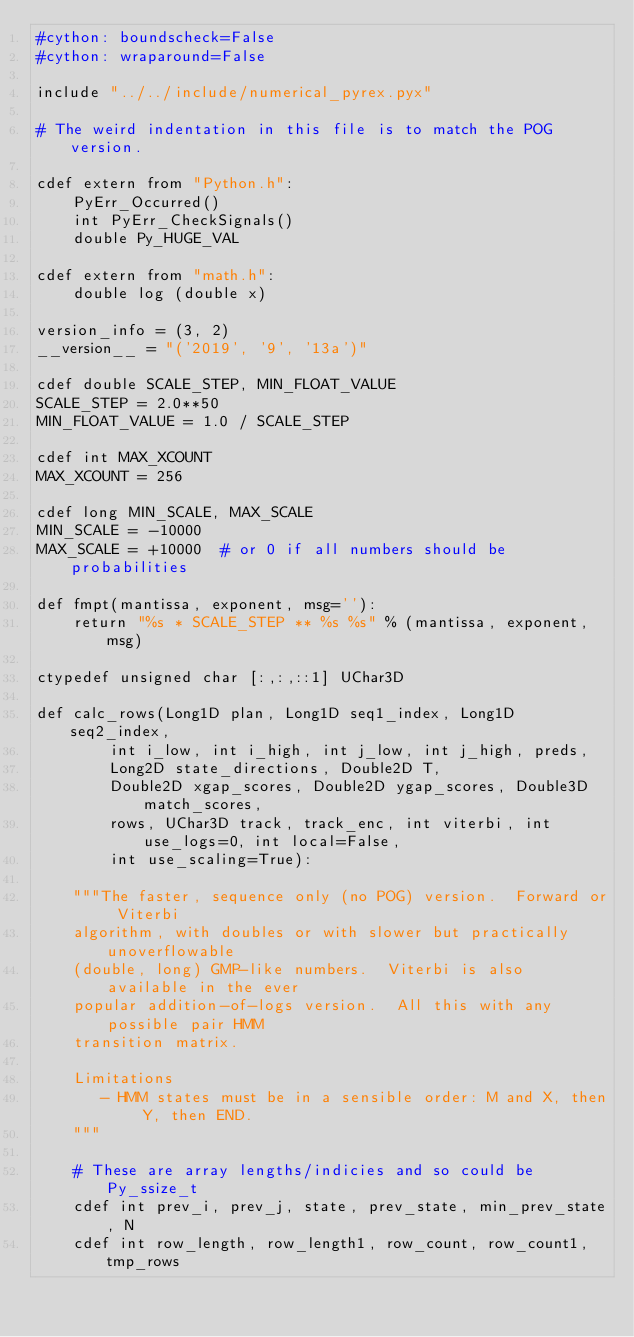<code> <loc_0><loc_0><loc_500><loc_500><_Cython_>#cython: boundscheck=False
#cython: wraparound=False

include "../../include/numerical_pyrex.pyx"

# The weird indentation in this file is to match the POG version.

cdef extern from "Python.h":
    PyErr_Occurred()
    int PyErr_CheckSignals()
    double Py_HUGE_VAL

cdef extern from "math.h":
    double log (double x)

version_info = (3, 2)
__version__ = "('2019', '9', '13a')"

cdef double SCALE_STEP, MIN_FLOAT_VALUE
SCALE_STEP = 2.0**50
MIN_FLOAT_VALUE = 1.0 / SCALE_STEP

cdef int MAX_XCOUNT
MAX_XCOUNT = 256

cdef long MIN_SCALE, MAX_SCALE
MIN_SCALE = -10000
MAX_SCALE = +10000  # or 0 if all numbers should be probabilities

def fmpt(mantissa, exponent, msg=''):
    return "%s * SCALE_STEP ** %s %s" % (mantissa, exponent, msg)

ctypedef unsigned char [:,:,::1] UChar3D

def calc_rows(Long1D plan, Long1D seq1_index, Long1D seq2_index, 
        int i_low, int i_high, int j_low, int j_high, preds, 
        Long2D state_directions, Double2D T, 
        Double2D xgap_scores, Double2D ygap_scores, Double3D match_scores, 
        rows, UChar3D track, track_enc, int viterbi, int use_logs=0, int local=False, 
        int use_scaling=True):
    
    """The faster, sequence only (no POG) version.  Forward or Viterbi 
    algorithm, with doubles or with slower but practically unoverflowable 
    (double, long) GMP-like numbers.  Viterbi is also available in the ever 
    popular addition-of-logs version.  All this with any possible pair HMM 
    transition matrix.
        
    Limitations
       - HMM states must be in a sensible order: M and X, then Y, then END.
    """
    
    # These are array lengths/indicies and so could be Py_ssize_t
    cdef int prev_i, prev_j, state, prev_state, min_prev_state, N
    cdef int row_length, row_length1, row_count, row_count1, tmp_rows</code> 